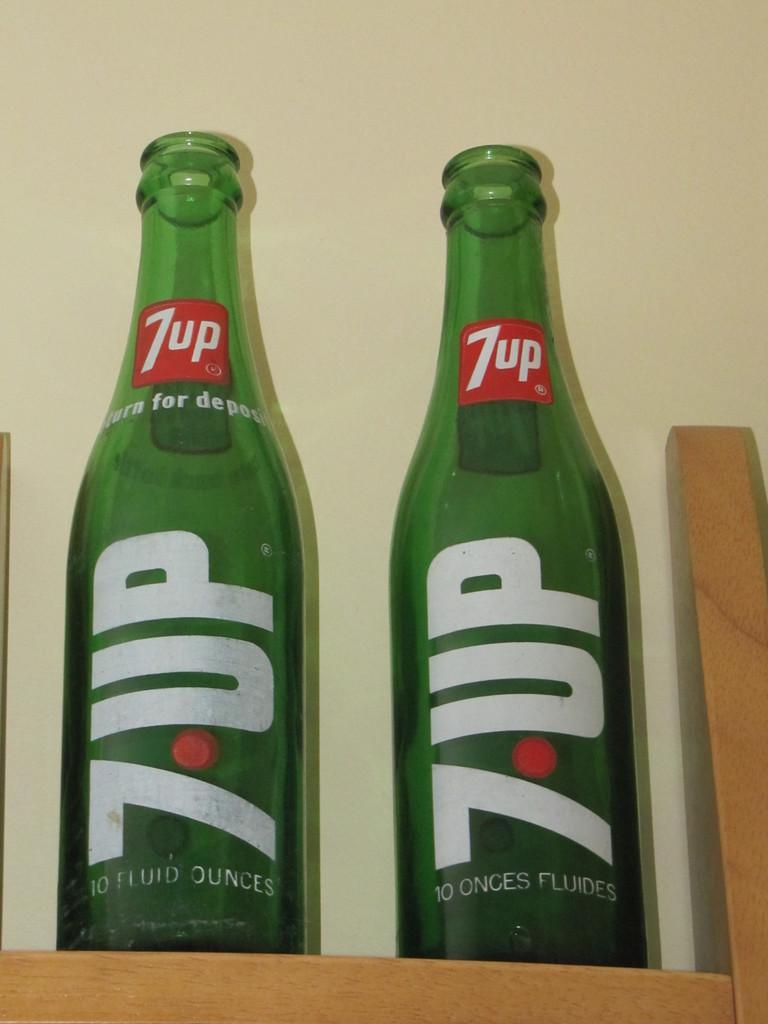How would you summarize this image in a sentence or two? In this image I can see two bottles which are in green color on the stand and the stand is in brown color, at the back I can see wall in cream color. 